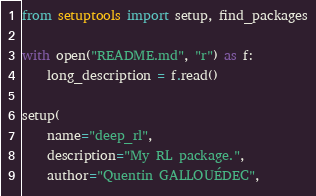Convert code to text. <code><loc_0><loc_0><loc_500><loc_500><_Python_>from setuptools import setup, find_packages

with open("README.md", "r") as f:
    long_description = f.read()

setup(
    name="deep_rl",
    description="My RL package.",
    author="Quentin GALLOUÉDEC",</code> 